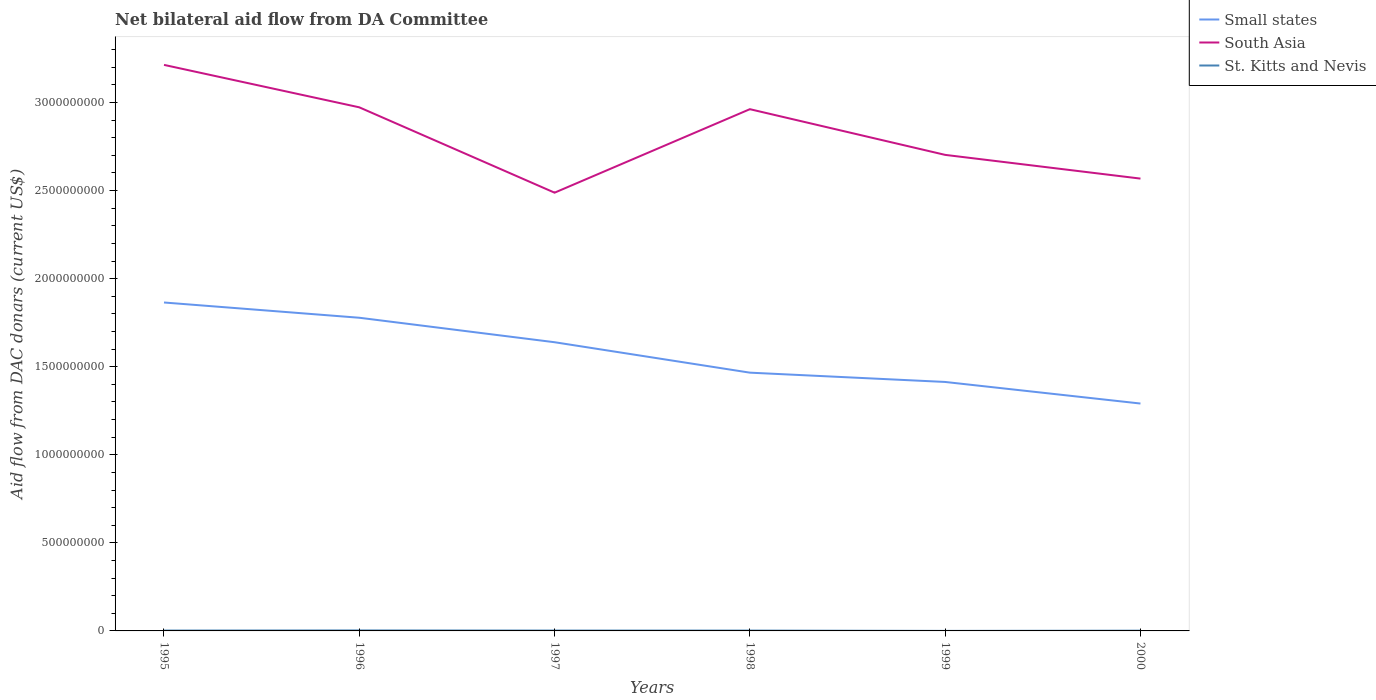Does the line corresponding to Small states intersect with the line corresponding to St. Kitts and Nevis?
Offer a very short reply. No. Across all years, what is the maximum aid flow in in St. Kitts and Nevis?
Your answer should be very brief. 1.70e+05. What is the total aid flow in in Small states in the graph?
Provide a succinct answer. 5.74e+08. What is the difference between the highest and the second highest aid flow in in St. Kitts and Nevis?
Your answer should be very brief. 2.56e+06. How many years are there in the graph?
Provide a short and direct response. 6. What is the difference between two consecutive major ticks on the Y-axis?
Offer a terse response. 5.00e+08. Does the graph contain any zero values?
Your answer should be compact. No. Does the graph contain grids?
Ensure brevity in your answer.  No. Where does the legend appear in the graph?
Your response must be concise. Top right. How are the legend labels stacked?
Make the answer very short. Vertical. What is the title of the graph?
Give a very brief answer. Net bilateral aid flow from DA Committee. Does "Turkmenistan" appear as one of the legend labels in the graph?
Provide a short and direct response. No. What is the label or title of the X-axis?
Offer a terse response. Years. What is the label or title of the Y-axis?
Provide a short and direct response. Aid flow from DAC donars (current US$). What is the Aid flow from DAC donars (current US$) in Small states in 1995?
Provide a succinct answer. 1.86e+09. What is the Aid flow from DAC donars (current US$) of South Asia in 1995?
Keep it short and to the point. 3.21e+09. What is the Aid flow from DAC donars (current US$) in St. Kitts and Nevis in 1995?
Provide a short and direct response. 2.02e+06. What is the Aid flow from DAC donars (current US$) in Small states in 1996?
Your answer should be very brief. 1.78e+09. What is the Aid flow from DAC donars (current US$) in South Asia in 1996?
Provide a succinct answer. 2.97e+09. What is the Aid flow from DAC donars (current US$) in St. Kitts and Nevis in 1996?
Your response must be concise. 2.73e+06. What is the Aid flow from DAC donars (current US$) in Small states in 1997?
Ensure brevity in your answer.  1.64e+09. What is the Aid flow from DAC donars (current US$) of South Asia in 1997?
Offer a very short reply. 2.49e+09. What is the Aid flow from DAC donars (current US$) of St. Kitts and Nevis in 1997?
Offer a very short reply. 2.07e+06. What is the Aid flow from DAC donars (current US$) of Small states in 1998?
Your response must be concise. 1.47e+09. What is the Aid flow from DAC donars (current US$) of South Asia in 1998?
Keep it short and to the point. 2.96e+09. What is the Aid flow from DAC donars (current US$) of St. Kitts and Nevis in 1998?
Keep it short and to the point. 1.95e+06. What is the Aid flow from DAC donars (current US$) in Small states in 1999?
Give a very brief answer. 1.41e+09. What is the Aid flow from DAC donars (current US$) in South Asia in 1999?
Provide a succinct answer. 2.70e+09. What is the Aid flow from DAC donars (current US$) in St. Kitts and Nevis in 1999?
Give a very brief answer. 1.70e+05. What is the Aid flow from DAC donars (current US$) of Small states in 2000?
Provide a short and direct response. 1.29e+09. What is the Aid flow from DAC donars (current US$) in South Asia in 2000?
Your response must be concise. 2.57e+09. What is the Aid flow from DAC donars (current US$) in St. Kitts and Nevis in 2000?
Ensure brevity in your answer.  1.39e+06. Across all years, what is the maximum Aid flow from DAC donars (current US$) of Small states?
Give a very brief answer. 1.86e+09. Across all years, what is the maximum Aid flow from DAC donars (current US$) in South Asia?
Make the answer very short. 3.21e+09. Across all years, what is the maximum Aid flow from DAC donars (current US$) of St. Kitts and Nevis?
Offer a terse response. 2.73e+06. Across all years, what is the minimum Aid flow from DAC donars (current US$) in Small states?
Ensure brevity in your answer.  1.29e+09. Across all years, what is the minimum Aid flow from DAC donars (current US$) of South Asia?
Make the answer very short. 2.49e+09. Across all years, what is the minimum Aid flow from DAC donars (current US$) of St. Kitts and Nevis?
Your answer should be compact. 1.70e+05. What is the total Aid flow from DAC donars (current US$) of Small states in the graph?
Keep it short and to the point. 9.45e+09. What is the total Aid flow from DAC donars (current US$) of South Asia in the graph?
Your answer should be compact. 1.69e+1. What is the total Aid flow from DAC donars (current US$) of St. Kitts and Nevis in the graph?
Keep it short and to the point. 1.03e+07. What is the difference between the Aid flow from DAC donars (current US$) in Small states in 1995 and that in 1996?
Your answer should be very brief. 8.66e+07. What is the difference between the Aid flow from DAC donars (current US$) in South Asia in 1995 and that in 1996?
Provide a short and direct response. 2.41e+08. What is the difference between the Aid flow from DAC donars (current US$) in St. Kitts and Nevis in 1995 and that in 1996?
Your answer should be compact. -7.10e+05. What is the difference between the Aid flow from DAC donars (current US$) of Small states in 1995 and that in 1997?
Your answer should be very brief. 2.26e+08. What is the difference between the Aid flow from DAC donars (current US$) in South Asia in 1995 and that in 1997?
Give a very brief answer. 7.26e+08. What is the difference between the Aid flow from DAC donars (current US$) in Small states in 1995 and that in 1998?
Your answer should be compact. 3.98e+08. What is the difference between the Aid flow from DAC donars (current US$) of South Asia in 1995 and that in 1998?
Provide a short and direct response. 2.52e+08. What is the difference between the Aid flow from DAC donars (current US$) of Small states in 1995 and that in 1999?
Give a very brief answer. 4.51e+08. What is the difference between the Aid flow from DAC donars (current US$) in South Asia in 1995 and that in 1999?
Make the answer very short. 5.11e+08. What is the difference between the Aid flow from DAC donars (current US$) in St. Kitts and Nevis in 1995 and that in 1999?
Keep it short and to the point. 1.85e+06. What is the difference between the Aid flow from DAC donars (current US$) in Small states in 1995 and that in 2000?
Offer a very short reply. 5.74e+08. What is the difference between the Aid flow from DAC donars (current US$) of South Asia in 1995 and that in 2000?
Ensure brevity in your answer.  6.46e+08. What is the difference between the Aid flow from DAC donars (current US$) in St. Kitts and Nevis in 1995 and that in 2000?
Give a very brief answer. 6.30e+05. What is the difference between the Aid flow from DAC donars (current US$) of Small states in 1996 and that in 1997?
Provide a succinct answer. 1.39e+08. What is the difference between the Aid flow from DAC donars (current US$) in South Asia in 1996 and that in 1997?
Your answer should be very brief. 4.85e+08. What is the difference between the Aid flow from DAC donars (current US$) of St. Kitts and Nevis in 1996 and that in 1997?
Provide a succinct answer. 6.60e+05. What is the difference between the Aid flow from DAC donars (current US$) of Small states in 1996 and that in 1998?
Keep it short and to the point. 3.12e+08. What is the difference between the Aid flow from DAC donars (current US$) in South Asia in 1996 and that in 1998?
Offer a terse response. 1.05e+07. What is the difference between the Aid flow from DAC donars (current US$) of St. Kitts and Nevis in 1996 and that in 1998?
Provide a short and direct response. 7.80e+05. What is the difference between the Aid flow from DAC donars (current US$) in Small states in 1996 and that in 1999?
Offer a terse response. 3.65e+08. What is the difference between the Aid flow from DAC donars (current US$) in South Asia in 1996 and that in 1999?
Your answer should be compact. 2.70e+08. What is the difference between the Aid flow from DAC donars (current US$) of St. Kitts and Nevis in 1996 and that in 1999?
Give a very brief answer. 2.56e+06. What is the difference between the Aid flow from DAC donars (current US$) of Small states in 1996 and that in 2000?
Make the answer very short. 4.87e+08. What is the difference between the Aid flow from DAC donars (current US$) in South Asia in 1996 and that in 2000?
Offer a terse response. 4.05e+08. What is the difference between the Aid flow from DAC donars (current US$) of St. Kitts and Nevis in 1996 and that in 2000?
Keep it short and to the point. 1.34e+06. What is the difference between the Aid flow from DAC donars (current US$) of Small states in 1997 and that in 1998?
Your answer should be very brief. 1.73e+08. What is the difference between the Aid flow from DAC donars (current US$) in South Asia in 1997 and that in 1998?
Offer a very short reply. -4.74e+08. What is the difference between the Aid flow from DAC donars (current US$) in St. Kitts and Nevis in 1997 and that in 1998?
Offer a very short reply. 1.20e+05. What is the difference between the Aid flow from DAC donars (current US$) in Small states in 1997 and that in 1999?
Keep it short and to the point. 2.26e+08. What is the difference between the Aid flow from DAC donars (current US$) in South Asia in 1997 and that in 1999?
Give a very brief answer. -2.15e+08. What is the difference between the Aid flow from DAC donars (current US$) of St. Kitts and Nevis in 1997 and that in 1999?
Keep it short and to the point. 1.90e+06. What is the difference between the Aid flow from DAC donars (current US$) of Small states in 1997 and that in 2000?
Keep it short and to the point. 3.48e+08. What is the difference between the Aid flow from DAC donars (current US$) in South Asia in 1997 and that in 2000?
Your response must be concise. -7.99e+07. What is the difference between the Aid flow from DAC donars (current US$) in St. Kitts and Nevis in 1997 and that in 2000?
Provide a short and direct response. 6.80e+05. What is the difference between the Aid flow from DAC donars (current US$) in Small states in 1998 and that in 1999?
Offer a terse response. 5.28e+07. What is the difference between the Aid flow from DAC donars (current US$) in South Asia in 1998 and that in 1999?
Ensure brevity in your answer.  2.59e+08. What is the difference between the Aid flow from DAC donars (current US$) of St. Kitts and Nevis in 1998 and that in 1999?
Provide a succinct answer. 1.78e+06. What is the difference between the Aid flow from DAC donars (current US$) of Small states in 1998 and that in 2000?
Provide a short and direct response. 1.75e+08. What is the difference between the Aid flow from DAC donars (current US$) in South Asia in 1998 and that in 2000?
Make the answer very short. 3.94e+08. What is the difference between the Aid flow from DAC donars (current US$) in St. Kitts and Nevis in 1998 and that in 2000?
Offer a very short reply. 5.60e+05. What is the difference between the Aid flow from DAC donars (current US$) of Small states in 1999 and that in 2000?
Provide a short and direct response. 1.23e+08. What is the difference between the Aid flow from DAC donars (current US$) of South Asia in 1999 and that in 2000?
Provide a short and direct response. 1.35e+08. What is the difference between the Aid flow from DAC donars (current US$) in St. Kitts and Nevis in 1999 and that in 2000?
Offer a very short reply. -1.22e+06. What is the difference between the Aid flow from DAC donars (current US$) in Small states in 1995 and the Aid flow from DAC donars (current US$) in South Asia in 1996?
Your answer should be very brief. -1.11e+09. What is the difference between the Aid flow from DAC donars (current US$) in Small states in 1995 and the Aid flow from DAC donars (current US$) in St. Kitts and Nevis in 1996?
Your answer should be compact. 1.86e+09. What is the difference between the Aid flow from DAC donars (current US$) of South Asia in 1995 and the Aid flow from DAC donars (current US$) of St. Kitts and Nevis in 1996?
Your answer should be compact. 3.21e+09. What is the difference between the Aid flow from DAC donars (current US$) in Small states in 1995 and the Aid flow from DAC donars (current US$) in South Asia in 1997?
Make the answer very short. -6.24e+08. What is the difference between the Aid flow from DAC donars (current US$) of Small states in 1995 and the Aid flow from DAC donars (current US$) of St. Kitts and Nevis in 1997?
Your answer should be compact. 1.86e+09. What is the difference between the Aid flow from DAC donars (current US$) in South Asia in 1995 and the Aid flow from DAC donars (current US$) in St. Kitts and Nevis in 1997?
Offer a very short reply. 3.21e+09. What is the difference between the Aid flow from DAC donars (current US$) of Small states in 1995 and the Aid flow from DAC donars (current US$) of South Asia in 1998?
Provide a short and direct response. -1.10e+09. What is the difference between the Aid flow from DAC donars (current US$) in Small states in 1995 and the Aid flow from DAC donars (current US$) in St. Kitts and Nevis in 1998?
Provide a short and direct response. 1.86e+09. What is the difference between the Aid flow from DAC donars (current US$) of South Asia in 1995 and the Aid flow from DAC donars (current US$) of St. Kitts and Nevis in 1998?
Give a very brief answer. 3.21e+09. What is the difference between the Aid flow from DAC donars (current US$) of Small states in 1995 and the Aid flow from DAC donars (current US$) of South Asia in 1999?
Ensure brevity in your answer.  -8.38e+08. What is the difference between the Aid flow from DAC donars (current US$) of Small states in 1995 and the Aid flow from DAC donars (current US$) of St. Kitts and Nevis in 1999?
Provide a short and direct response. 1.86e+09. What is the difference between the Aid flow from DAC donars (current US$) in South Asia in 1995 and the Aid flow from DAC donars (current US$) in St. Kitts and Nevis in 1999?
Offer a terse response. 3.21e+09. What is the difference between the Aid flow from DAC donars (current US$) in Small states in 1995 and the Aid flow from DAC donars (current US$) in South Asia in 2000?
Your answer should be very brief. -7.03e+08. What is the difference between the Aid flow from DAC donars (current US$) of Small states in 1995 and the Aid flow from DAC donars (current US$) of St. Kitts and Nevis in 2000?
Ensure brevity in your answer.  1.86e+09. What is the difference between the Aid flow from DAC donars (current US$) in South Asia in 1995 and the Aid flow from DAC donars (current US$) in St. Kitts and Nevis in 2000?
Your response must be concise. 3.21e+09. What is the difference between the Aid flow from DAC donars (current US$) of Small states in 1996 and the Aid flow from DAC donars (current US$) of South Asia in 1997?
Give a very brief answer. -7.10e+08. What is the difference between the Aid flow from DAC donars (current US$) of Small states in 1996 and the Aid flow from DAC donars (current US$) of St. Kitts and Nevis in 1997?
Your answer should be very brief. 1.78e+09. What is the difference between the Aid flow from DAC donars (current US$) in South Asia in 1996 and the Aid flow from DAC donars (current US$) in St. Kitts and Nevis in 1997?
Keep it short and to the point. 2.97e+09. What is the difference between the Aid flow from DAC donars (current US$) in Small states in 1996 and the Aid flow from DAC donars (current US$) in South Asia in 1998?
Offer a terse response. -1.18e+09. What is the difference between the Aid flow from DAC donars (current US$) in Small states in 1996 and the Aid flow from DAC donars (current US$) in St. Kitts and Nevis in 1998?
Your answer should be compact. 1.78e+09. What is the difference between the Aid flow from DAC donars (current US$) in South Asia in 1996 and the Aid flow from DAC donars (current US$) in St. Kitts and Nevis in 1998?
Keep it short and to the point. 2.97e+09. What is the difference between the Aid flow from DAC donars (current US$) in Small states in 1996 and the Aid flow from DAC donars (current US$) in South Asia in 1999?
Keep it short and to the point. -9.25e+08. What is the difference between the Aid flow from DAC donars (current US$) in Small states in 1996 and the Aid flow from DAC donars (current US$) in St. Kitts and Nevis in 1999?
Ensure brevity in your answer.  1.78e+09. What is the difference between the Aid flow from DAC donars (current US$) in South Asia in 1996 and the Aid flow from DAC donars (current US$) in St. Kitts and Nevis in 1999?
Your answer should be very brief. 2.97e+09. What is the difference between the Aid flow from DAC donars (current US$) of Small states in 1996 and the Aid flow from DAC donars (current US$) of South Asia in 2000?
Provide a succinct answer. -7.90e+08. What is the difference between the Aid flow from DAC donars (current US$) of Small states in 1996 and the Aid flow from DAC donars (current US$) of St. Kitts and Nevis in 2000?
Offer a terse response. 1.78e+09. What is the difference between the Aid flow from DAC donars (current US$) of South Asia in 1996 and the Aid flow from DAC donars (current US$) of St. Kitts and Nevis in 2000?
Your answer should be very brief. 2.97e+09. What is the difference between the Aid flow from DAC donars (current US$) of Small states in 1997 and the Aid flow from DAC donars (current US$) of South Asia in 1998?
Ensure brevity in your answer.  -1.32e+09. What is the difference between the Aid flow from DAC donars (current US$) in Small states in 1997 and the Aid flow from DAC donars (current US$) in St. Kitts and Nevis in 1998?
Make the answer very short. 1.64e+09. What is the difference between the Aid flow from DAC donars (current US$) of South Asia in 1997 and the Aid flow from DAC donars (current US$) of St. Kitts and Nevis in 1998?
Make the answer very short. 2.49e+09. What is the difference between the Aid flow from DAC donars (current US$) in Small states in 1997 and the Aid flow from DAC donars (current US$) in South Asia in 1999?
Offer a very short reply. -1.06e+09. What is the difference between the Aid flow from DAC donars (current US$) in Small states in 1997 and the Aid flow from DAC donars (current US$) in St. Kitts and Nevis in 1999?
Make the answer very short. 1.64e+09. What is the difference between the Aid flow from DAC donars (current US$) in South Asia in 1997 and the Aid flow from DAC donars (current US$) in St. Kitts and Nevis in 1999?
Your response must be concise. 2.49e+09. What is the difference between the Aid flow from DAC donars (current US$) of Small states in 1997 and the Aid flow from DAC donars (current US$) of South Asia in 2000?
Your response must be concise. -9.29e+08. What is the difference between the Aid flow from DAC donars (current US$) in Small states in 1997 and the Aid flow from DAC donars (current US$) in St. Kitts and Nevis in 2000?
Keep it short and to the point. 1.64e+09. What is the difference between the Aid flow from DAC donars (current US$) in South Asia in 1997 and the Aid flow from DAC donars (current US$) in St. Kitts and Nevis in 2000?
Give a very brief answer. 2.49e+09. What is the difference between the Aid flow from DAC donars (current US$) of Small states in 1998 and the Aid flow from DAC donars (current US$) of South Asia in 1999?
Provide a short and direct response. -1.24e+09. What is the difference between the Aid flow from DAC donars (current US$) of Small states in 1998 and the Aid flow from DAC donars (current US$) of St. Kitts and Nevis in 1999?
Give a very brief answer. 1.47e+09. What is the difference between the Aid flow from DAC donars (current US$) in South Asia in 1998 and the Aid flow from DAC donars (current US$) in St. Kitts and Nevis in 1999?
Your answer should be compact. 2.96e+09. What is the difference between the Aid flow from DAC donars (current US$) in Small states in 1998 and the Aid flow from DAC donars (current US$) in South Asia in 2000?
Your response must be concise. -1.10e+09. What is the difference between the Aid flow from DAC donars (current US$) of Small states in 1998 and the Aid flow from DAC donars (current US$) of St. Kitts and Nevis in 2000?
Provide a succinct answer. 1.46e+09. What is the difference between the Aid flow from DAC donars (current US$) in South Asia in 1998 and the Aid flow from DAC donars (current US$) in St. Kitts and Nevis in 2000?
Ensure brevity in your answer.  2.96e+09. What is the difference between the Aid flow from DAC donars (current US$) of Small states in 1999 and the Aid flow from DAC donars (current US$) of South Asia in 2000?
Ensure brevity in your answer.  -1.15e+09. What is the difference between the Aid flow from DAC donars (current US$) of Small states in 1999 and the Aid flow from DAC donars (current US$) of St. Kitts and Nevis in 2000?
Provide a short and direct response. 1.41e+09. What is the difference between the Aid flow from DAC donars (current US$) of South Asia in 1999 and the Aid flow from DAC donars (current US$) of St. Kitts and Nevis in 2000?
Make the answer very short. 2.70e+09. What is the average Aid flow from DAC donars (current US$) in Small states per year?
Give a very brief answer. 1.58e+09. What is the average Aid flow from DAC donars (current US$) in South Asia per year?
Keep it short and to the point. 2.82e+09. What is the average Aid flow from DAC donars (current US$) of St. Kitts and Nevis per year?
Keep it short and to the point. 1.72e+06. In the year 1995, what is the difference between the Aid flow from DAC donars (current US$) of Small states and Aid flow from DAC donars (current US$) of South Asia?
Provide a succinct answer. -1.35e+09. In the year 1995, what is the difference between the Aid flow from DAC donars (current US$) of Small states and Aid flow from DAC donars (current US$) of St. Kitts and Nevis?
Offer a terse response. 1.86e+09. In the year 1995, what is the difference between the Aid flow from DAC donars (current US$) of South Asia and Aid flow from DAC donars (current US$) of St. Kitts and Nevis?
Make the answer very short. 3.21e+09. In the year 1996, what is the difference between the Aid flow from DAC donars (current US$) in Small states and Aid flow from DAC donars (current US$) in South Asia?
Provide a succinct answer. -1.19e+09. In the year 1996, what is the difference between the Aid flow from DAC donars (current US$) in Small states and Aid flow from DAC donars (current US$) in St. Kitts and Nevis?
Offer a terse response. 1.78e+09. In the year 1996, what is the difference between the Aid flow from DAC donars (current US$) of South Asia and Aid flow from DAC donars (current US$) of St. Kitts and Nevis?
Offer a very short reply. 2.97e+09. In the year 1997, what is the difference between the Aid flow from DAC donars (current US$) of Small states and Aid flow from DAC donars (current US$) of South Asia?
Offer a terse response. -8.49e+08. In the year 1997, what is the difference between the Aid flow from DAC donars (current US$) in Small states and Aid flow from DAC donars (current US$) in St. Kitts and Nevis?
Keep it short and to the point. 1.64e+09. In the year 1997, what is the difference between the Aid flow from DAC donars (current US$) of South Asia and Aid flow from DAC donars (current US$) of St. Kitts and Nevis?
Offer a terse response. 2.49e+09. In the year 1998, what is the difference between the Aid flow from DAC donars (current US$) in Small states and Aid flow from DAC donars (current US$) in South Asia?
Make the answer very short. -1.50e+09. In the year 1998, what is the difference between the Aid flow from DAC donars (current US$) in Small states and Aid flow from DAC donars (current US$) in St. Kitts and Nevis?
Your answer should be compact. 1.46e+09. In the year 1998, what is the difference between the Aid flow from DAC donars (current US$) in South Asia and Aid flow from DAC donars (current US$) in St. Kitts and Nevis?
Offer a very short reply. 2.96e+09. In the year 1999, what is the difference between the Aid flow from DAC donars (current US$) of Small states and Aid flow from DAC donars (current US$) of South Asia?
Give a very brief answer. -1.29e+09. In the year 1999, what is the difference between the Aid flow from DAC donars (current US$) of Small states and Aid flow from DAC donars (current US$) of St. Kitts and Nevis?
Your answer should be compact. 1.41e+09. In the year 1999, what is the difference between the Aid flow from DAC donars (current US$) of South Asia and Aid flow from DAC donars (current US$) of St. Kitts and Nevis?
Your answer should be very brief. 2.70e+09. In the year 2000, what is the difference between the Aid flow from DAC donars (current US$) of Small states and Aid flow from DAC donars (current US$) of South Asia?
Your response must be concise. -1.28e+09. In the year 2000, what is the difference between the Aid flow from DAC donars (current US$) in Small states and Aid flow from DAC donars (current US$) in St. Kitts and Nevis?
Provide a succinct answer. 1.29e+09. In the year 2000, what is the difference between the Aid flow from DAC donars (current US$) in South Asia and Aid flow from DAC donars (current US$) in St. Kitts and Nevis?
Your response must be concise. 2.57e+09. What is the ratio of the Aid flow from DAC donars (current US$) of Small states in 1995 to that in 1996?
Your answer should be very brief. 1.05. What is the ratio of the Aid flow from DAC donars (current US$) of South Asia in 1995 to that in 1996?
Offer a terse response. 1.08. What is the ratio of the Aid flow from DAC donars (current US$) of St. Kitts and Nevis in 1995 to that in 1996?
Your answer should be compact. 0.74. What is the ratio of the Aid flow from DAC donars (current US$) in Small states in 1995 to that in 1997?
Offer a very short reply. 1.14. What is the ratio of the Aid flow from DAC donars (current US$) in South Asia in 1995 to that in 1997?
Provide a short and direct response. 1.29. What is the ratio of the Aid flow from DAC donars (current US$) of St. Kitts and Nevis in 1995 to that in 1997?
Your response must be concise. 0.98. What is the ratio of the Aid flow from DAC donars (current US$) of Small states in 1995 to that in 1998?
Provide a short and direct response. 1.27. What is the ratio of the Aid flow from DAC donars (current US$) in South Asia in 1995 to that in 1998?
Your response must be concise. 1.08. What is the ratio of the Aid flow from DAC donars (current US$) of St. Kitts and Nevis in 1995 to that in 1998?
Your answer should be compact. 1.04. What is the ratio of the Aid flow from DAC donars (current US$) in Small states in 1995 to that in 1999?
Ensure brevity in your answer.  1.32. What is the ratio of the Aid flow from DAC donars (current US$) of South Asia in 1995 to that in 1999?
Ensure brevity in your answer.  1.19. What is the ratio of the Aid flow from DAC donars (current US$) of St. Kitts and Nevis in 1995 to that in 1999?
Your response must be concise. 11.88. What is the ratio of the Aid flow from DAC donars (current US$) of Small states in 1995 to that in 2000?
Offer a terse response. 1.44. What is the ratio of the Aid flow from DAC donars (current US$) in South Asia in 1995 to that in 2000?
Offer a very short reply. 1.25. What is the ratio of the Aid flow from DAC donars (current US$) in St. Kitts and Nevis in 1995 to that in 2000?
Provide a short and direct response. 1.45. What is the ratio of the Aid flow from DAC donars (current US$) of Small states in 1996 to that in 1997?
Provide a succinct answer. 1.08. What is the ratio of the Aid flow from DAC donars (current US$) in South Asia in 1996 to that in 1997?
Make the answer very short. 1.19. What is the ratio of the Aid flow from DAC donars (current US$) in St. Kitts and Nevis in 1996 to that in 1997?
Your answer should be compact. 1.32. What is the ratio of the Aid flow from DAC donars (current US$) of Small states in 1996 to that in 1998?
Keep it short and to the point. 1.21. What is the ratio of the Aid flow from DAC donars (current US$) of South Asia in 1996 to that in 1998?
Offer a terse response. 1. What is the ratio of the Aid flow from DAC donars (current US$) of Small states in 1996 to that in 1999?
Your answer should be compact. 1.26. What is the ratio of the Aid flow from DAC donars (current US$) in South Asia in 1996 to that in 1999?
Offer a very short reply. 1.1. What is the ratio of the Aid flow from DAC donars (current US$) of St. Kitts and Nevis in 1996 to that in 1999?
Keep it short and to the point. 16.06. What is the ratio of the Aid flow from DAC donars (current US$) of Small states in 1996 to that in 2000?
Your answer should be very brief. 1.38. What is the ratio of the Aid flow from DAC donars (current US$) in South Asia in 1996 to that in 2000?
Make the answer very short. 1.16. What is the ratio of the Aid flow from DAC donars (current US$) of St. Kitts and Nevis in 1996 to that in 2000?
Your answer should be very brief. 1.96. What is the ratio of the Aid flow from DAC donars (current US$) of Small states in 1997 to that in 1998?
Keep it short and to the point. 1.12. What is the ratio of the Aid flow from DAC donars (current US$) of South Asia in 1997 to that in 1998?
Ensure brevity in your answer.  0.84. What is the ratio of the Aid flow from DAC donars (current US$) in St. Kitts and Nevis in 1997 to that in 1998?
Offer a terse response. 1.06. What is the ratio of the Aid flow from DAC donars (current US$) in Small states in 1997 to that in 1999?
Provide a short and direct response. 1.16. What is the ratio of the Aid flow from DAC donars (current US$) of South Asia in 1997 to that in 1999?
Keep it short and to the point. 0.92. What is the ratio of the Aid flow from DAC donars (current US$) of St. Kitts and Nevis in 1997 to that in 1999?
Your answer should be compact. 12.18. What is the ratio of the Aid flow from DAC donars (current US$) of Small states in 1997 to that in 2000?
Give a very brief answer. 1.27. What is the ratio of the Aid flow from DAC donars (current US$) in South Asia in 1997 to that in 2000?
Offer a very short reply. 0.97. What is the ratio of the Aid flow from DAC donars (current US$) in St. Kitts and Nevis in 1997 to that in 2000?
Your response must be concise. 1.49. What is the ratio of the Aid flow from DAC donars (current US$) in Small states in 1998 to that in 1999?
Provide a succinct answer. 1.04. What is the ratio of the Aid flow from DAC donars (current US$) in South Asia in 1998 to that in 1999?
Your answer should be compact. 1.1. What is the ratio of the Aid flow from DAC donars (current US$) in St. Kitts and Nevis in 1998 to that in 1999?
Your response must be concise. 11.47. What is the ratio of the Aid flow from DAC donars (current US$) of Small states in 1998 to that in 2000?
Keep it short and to the point. 1.14. What is the ratio of the Aid flow from DAC donars (current US$) of South Asia in 1998 to that in 2000?
Offer a terse response. 1.15. What is the ratio of the Aid flow from DAC donars (current US$) in St. Kitts and Nevis in 1998 to that in 2000?
Offer a very short reply. 1.4. What is the ratio of the Aid flow from DAC donars (current US$) of Small states in 1999 to that in 2000?
Ensure brevity in your answer.  1.09. What is the ratio of the Aid flow from DAC donars (current US$) in South Asia in 1999 to that in 2000?
Your response must be concise. 1.05. What is the ratio of the Aid flow from DAC donars (current US$) in St. Kitts and Nevis in 1999 to that in 2000?
Provide a succinct answer. 0.12. What is the difference between the highest and the second highest Aid flow from DAC donars (current US$) of Small states?
Your response must be concise. 8.66e+07. What is the difference between the highest and the second highest Aid flow from DAC donars (current US$) of South Asia?
Your response must be concise. 2.41e+08. What is the difference between the highest and the second highest Aid flow from DAC donars (current US$) of St. Kitts and Nevis?
Your answer should be very brief. 6.60e+05. What is the difference between the highest and the lowest Aid flow from DAC donars (current US$) in Small states?
Offer a very short reply. 5.74e+08. What is the difference between the highest and the lowest Aid flow from DAC donars (current US$) in South Asia?
Your answer should be compact. 7.26e+08. What is the difference between the highest and the lowest Aid flow from DAC donars (current US$) of St. Kitts and Nevis?
Offer a very short reply. 2.56e+06. 